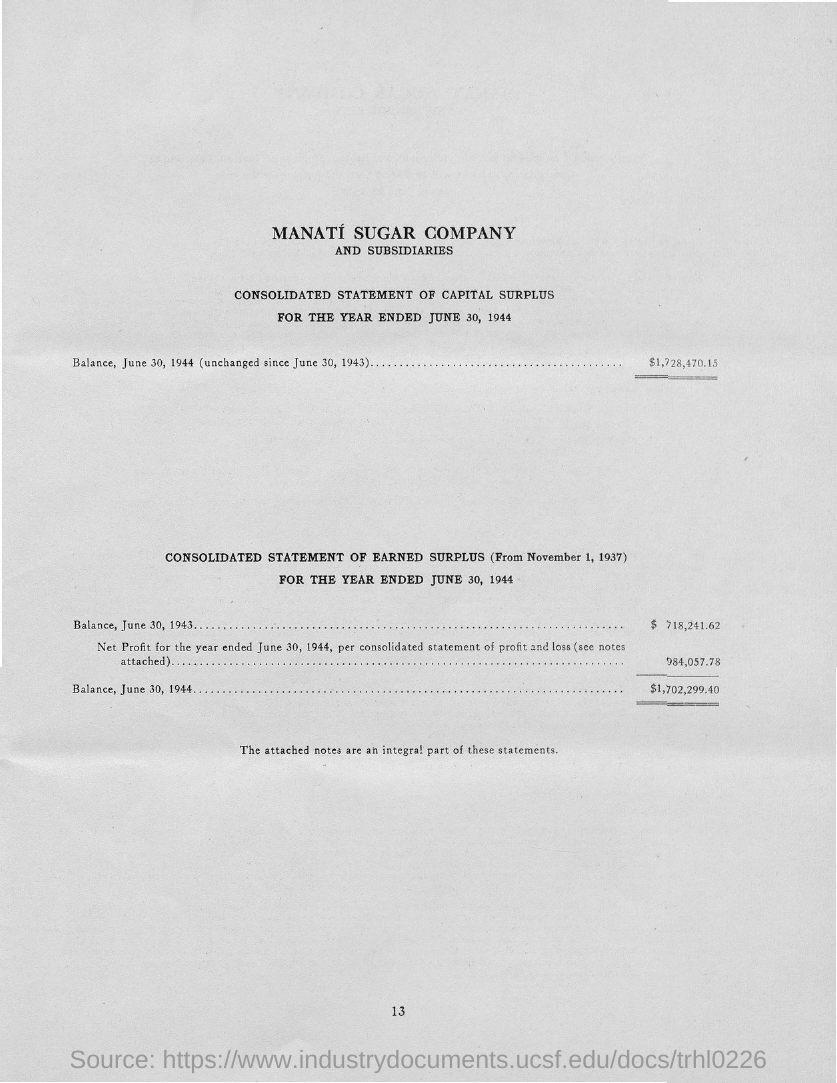What is the Page Number?
Make the answer very short. 13. 